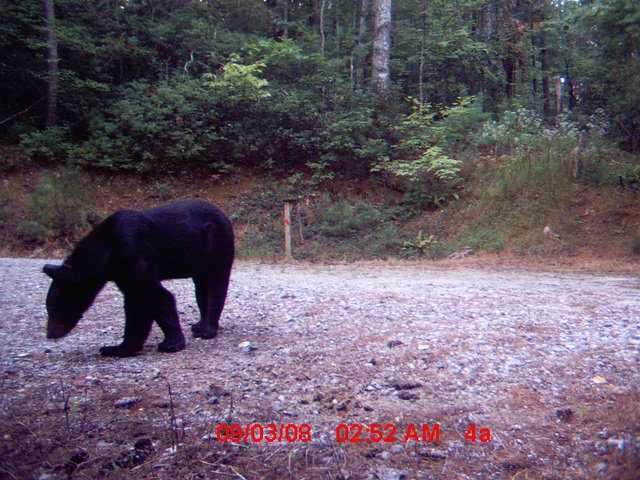Describe the objects in this image and their specific colors. I can see a bear in black, navy, gray, and purple tones in this image. 